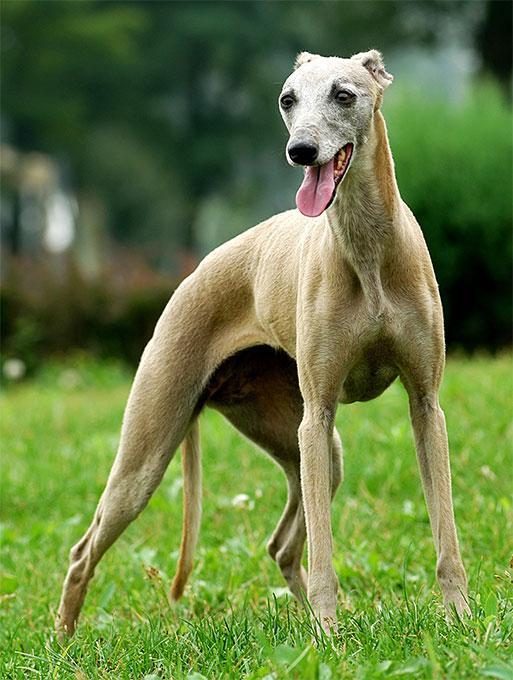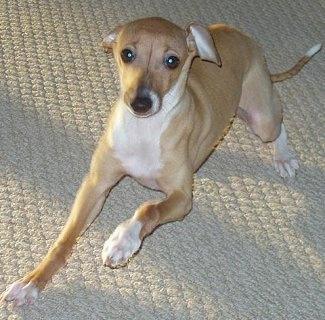The first image is the image on the left, the second image is the image on the right. Examine the images to the left and right. Is the description "One of the dogs is resting on a couch." accurate? Answer yes or no. No. The first image is the image on the left, the second image is the image on the right. Evaluate the accuracy of this statement regarding the images: "One image shows a mostly light brown dog standing on all fours in the grass.". Is it true? Answer yes or no. Yes. 